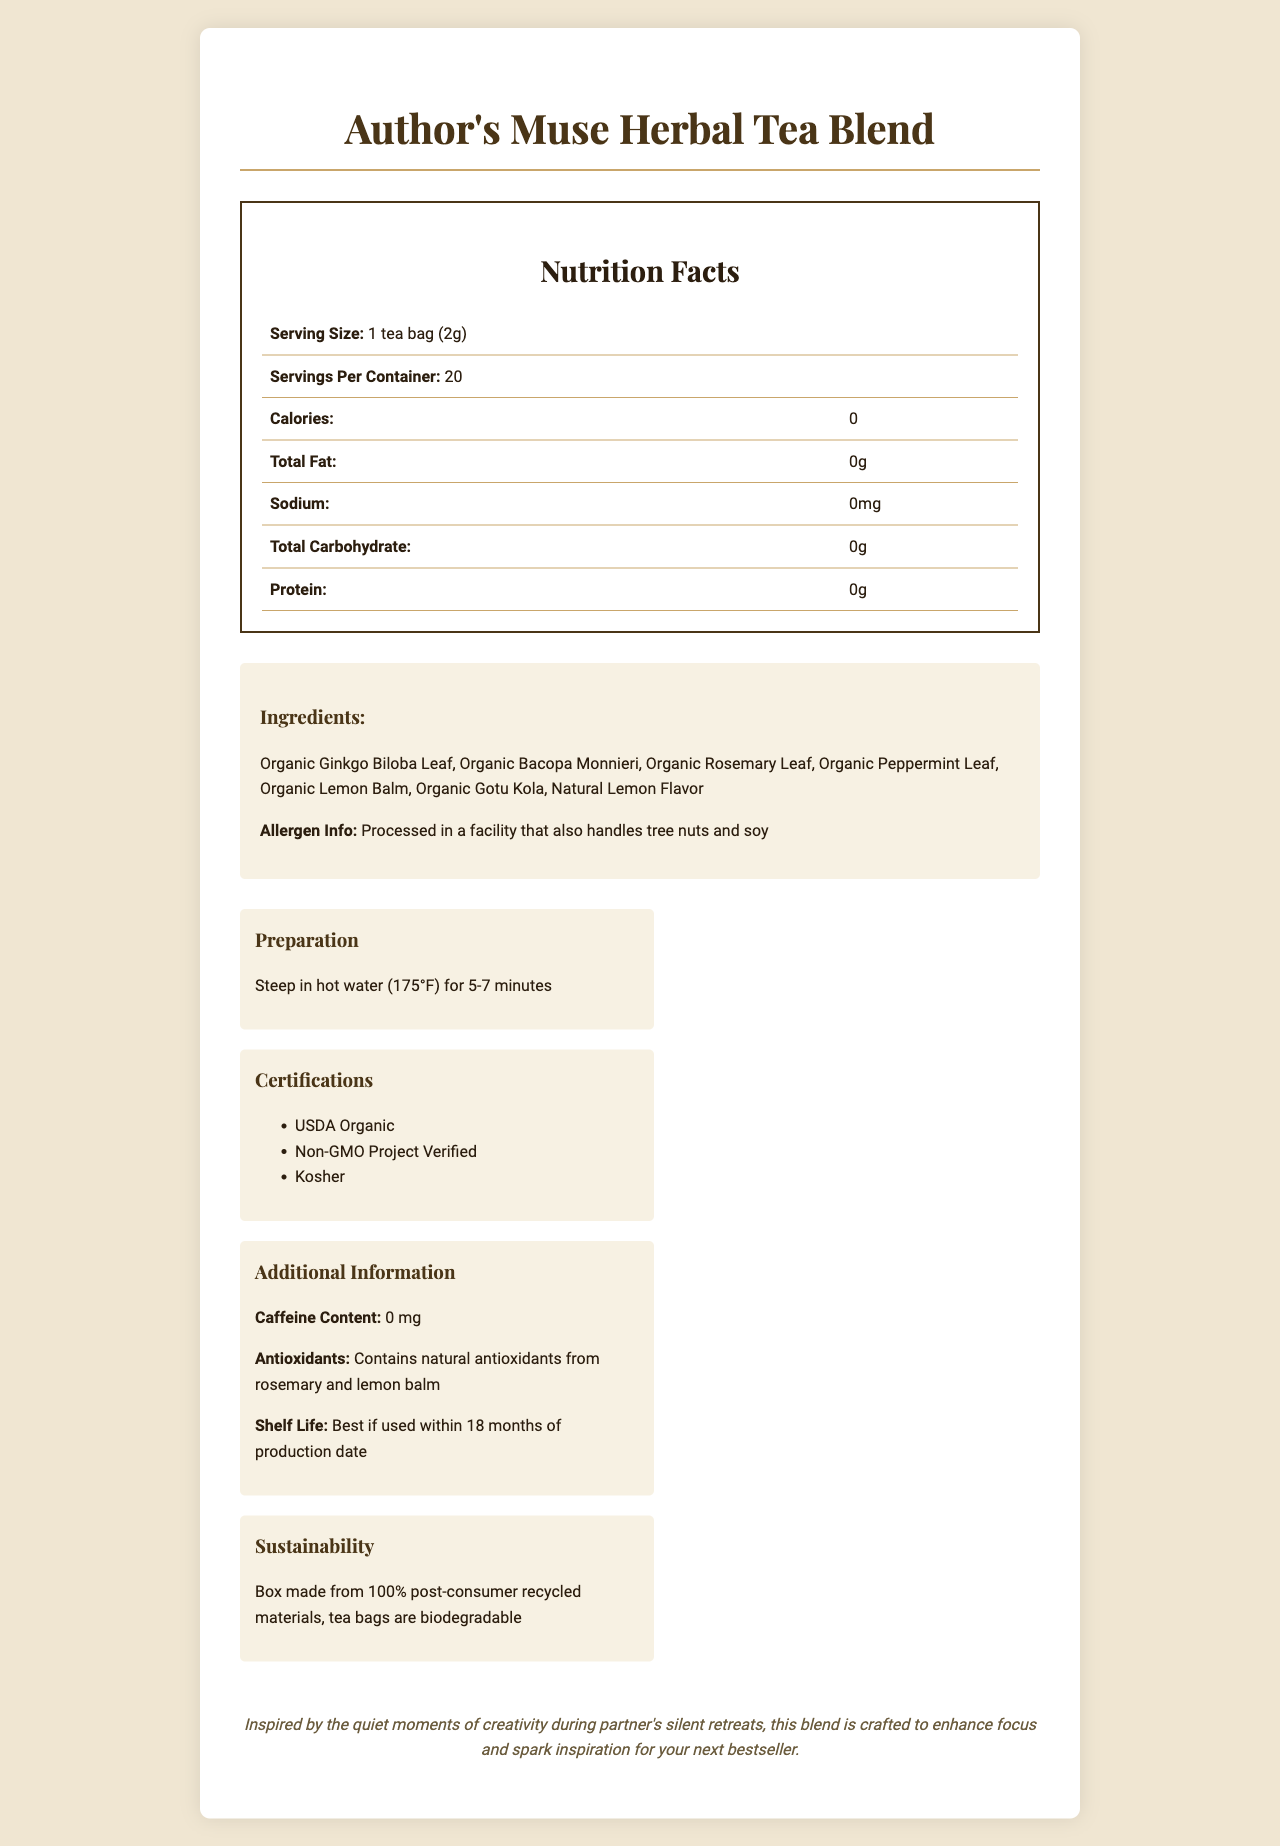what is the serving size for the Author's Muse Herbal Tea Blend? The serving size is clearly stated as "1 tea bag (2g)" in the nutrition label section of the document.
Answer: 1 tea bag (2g) how many servings are there per container? The document mentions that there are 20 servings per container.
Answer: 20 how many calories are there per serving? The nutrition facts indicate that each serving contains 0 calories.
Answer: 0 what is the total fat content per serving? The total fat content per serving is listed as 0g in the nutrition facts.
Answer: 0g what allergens might this product potentially contain? The allergen information states that the product is processed in a facility that also handles tree nuts and soy.
Answer: Tree nuts and soy what is the suggested steeping time and temperature for this tea? The preparation instructions specify to steep in hot water at 175°F for 5-7 minutes.
Answer: Steep in hot water (175°F) for 5-7 minutes which ingredients are included in the Author's Muse Herbal Tea Blend? The ingredients section lists all these components.
Answer: Organic Ginkgo Biloba Leaf, Organic Bacopa Monnieri, Organic Rosemary Leaf, Organic Peppermint Leaf, Organic Lemon Balm, Organic Gotu Kola, Natural Lemon Flavor what is this tea's caffeine content? The additional information section indicates that the tea contains 0 mg of caffeine.
Answer: 0 mg where are the herbs for this tea sourced from? The document states that the herbs are sourced from organic farms in India, Egypt, and Morocco.
Answer: India, Egypt, and Morocco how long is the shelf life of this product? The additional information specifies that the tea is best if used within 18 months of production date.
Answer: 18 months which certification(s) does the Author's Muse Herbal Tea Blend have? The certifications section lists all these certifications.
Answer: USDA Organic, Non-GMO Project Verified, Kosher what materials are the tea bags and packaging made from? A. Plastic B. Recycled cardboard and biodegradable materials C. Aluminum D. Glass The sustainability section notes that the box is made from 100% post-consumer recycled materials and the tea bags are biodegradable.
Answer: B what type of moments is this tea suggested to pair well with? A. Exercise B. Cooking C. Journaling and brainstorming sessions D. Watching TV The suggested pairing states it pairs well with journaling, brainstorming sessions, or quiet moments of reflection.
Answer: C is this tea blend suitable for someone on a gluten-free diet? The document does not provide information about whether the product is suitable for a gluten-free diet.
Answer: Cannot be determined does the Author's Muse Herbal Tea Blend contain any vitamins or minerals? The nutrition facts indicate that it contains 0% Vitamin A, Vitamin C, Calcium, and Iron.
Answer: No what is the primary focus of the "Author's Muse Herbal Tea Blend" brand story? The brand story mentions that the blend is crafted to enhance focus and spark inspiration for writing during silent retreats.
Answer: Enhancing focus and sparking inspiration for writers during quiet moments which certifications does this product have? A. USDA Organic B. Non-GMO Project Verified C. Kosher D. All of the above The certifications section shows that the tea has USDA Organic, Non-GMO Project Verified, and Kosher certifications.
Answer: D describe the main idea of the document. The document highlights the benefits, ingredients, sourcing, and sustainable practices of the Author's Muse Herbal Tea Blend designed to enhance focus and creativity for writers.
Answer: The document provides detailed information about the Author's Muse Herbal Tea Blend, including its nutrition facts, ingredient list, allergen information, preparation instructions, certifications, additional information about caffeine content and antioxidants, brand story, suggested pairings, and sustainability practices. 